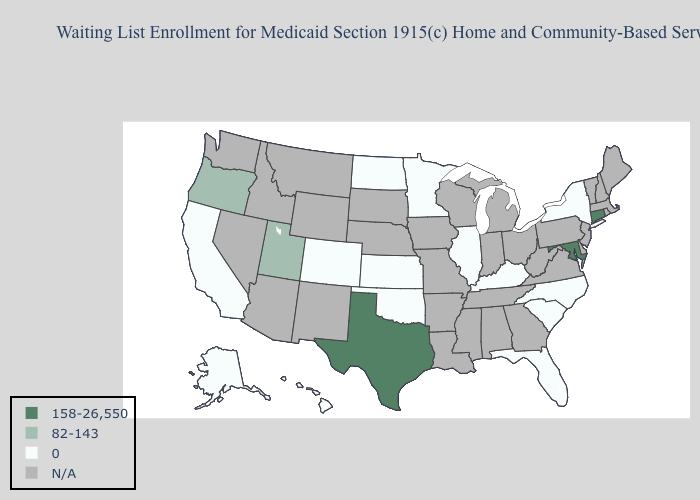Which states have the lowest value in the USA?
Write a very short answer. Alaska, California, Colorado, Florida, Hawaii, Illinois, Kansas, Kentucky, Minnesota, New York, North Carolina, North Dakota, Oklahoma, South Carolina. Name the states that have a value in the range 158-26,550?
Concise answer only. Connecticut, Maryland, Texas. Name the states that have a value in the range N/A?
Answer briefly. Alabama, Arizona, Arkansas, Delaware, Georgia, Idaho, Indiana, Iowa, Louisiana, Maine, Massachusetts, Michigan, Mississippi, Missouri, Montana, Nebraska, Nevada, New Hampshire, New Jersey, New Mexico, Ohio, Pennsylvania, Rhode Island, South Dakota, Tennessee, Vermont, Virginia, Washington, West Virginia, Wisconsin, Wyoming. Which states have the lowest value in the USA?
Keep it brief. Alaska, California, Colorado, Florida, Hawaii, Illinois, Kansas, Kentucky, Minnesota, New York, North Carolina, North Dakota, Oklahoma, South Carolina. Name the states that have a value in the range 82-143?
Answer briefly. Oregon, Utah. Does the map have missing data?
Concise answer only. Yes. What is the highest value in the South ?
Write a very short answer. 158-26,550. What is the value of Tennessee?
Answer briefly. N/A. Name the states that have a value in the range 158-26,550?
Concise answer only. Connecticut, Maryland, Texas. Name the states that have a value in the range 0?
Quick response, please. Alaska, California, Colorado, Florida, Hawaii, Illinois, Kansas, Kentucky, Minnesota, New York, North Carolina, North Dakota, Oklahoma, South Carolina. Name the states that have a value in the range 0?
Answer briefly. Alaska, California, Colorado, Florida, Hawaii, Illinois, Kansas, Kentucky, Minnesota, New York, North Carolina, North Dakota, Oklahoma, South Carolina. Does Connecticut have the highest value in the USA?
Short answer required. Yes. 